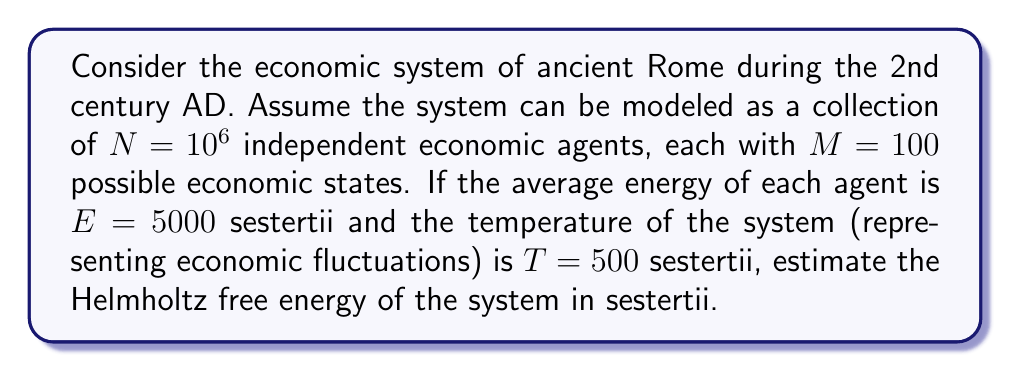Help me with this question. To estimate the Helmholtz free energy of this historical economic system, we'll use the following steps:

1) The Helmholtz free energy is given by the equation:

   $$F = E - TS$$

   where $F$ is the free energy, $E$ is the total energy, $T$ is the temperature, and $S$ is the entropy.

2) We're given the average energy per agent ($E = 5000$ sestertii) and the number of agents ($N = 10^6$). The total energy of the system is:

   $$E_{total} = N \cdot E = 10^6 \cdot 5000 = 5 \cdot 10^9 \text{ sestertii}$$

3) To calculate the entropy, we'll use the Boltzmann formula:

   $$S = k_B \ln W$$

   where $k_B$ is Boltzmann's constant (which we'll assume to be 1 for simplicity in this economic context) and $W$ is the number of microstates.

4) With $N$ agents and $M$ states per agent, the total number of microstates is:

   $$W = M^N = 100^{10^6}$$

5) Therefore, the entropy is:

   $$S = \ln(100^{10^6}) = 10^6 \ln(100) \approx 4.61 \cdot 10^6$$

6) Now we can calculate the free energy:

   $$F = E_{total} - TS$$
   $$F = 5 \cdot 10^9 - 500 \cdot (4.61 \cdot 10^6)$$
   $$F = 5 \cdot 10^9 - 2.305 \cdot 10^9$$
   $$F \approx 2.695 \cdot 10^9 \text{ sestertii}$$
Answer: $2.695 \cdot 10^9$ sestertii 